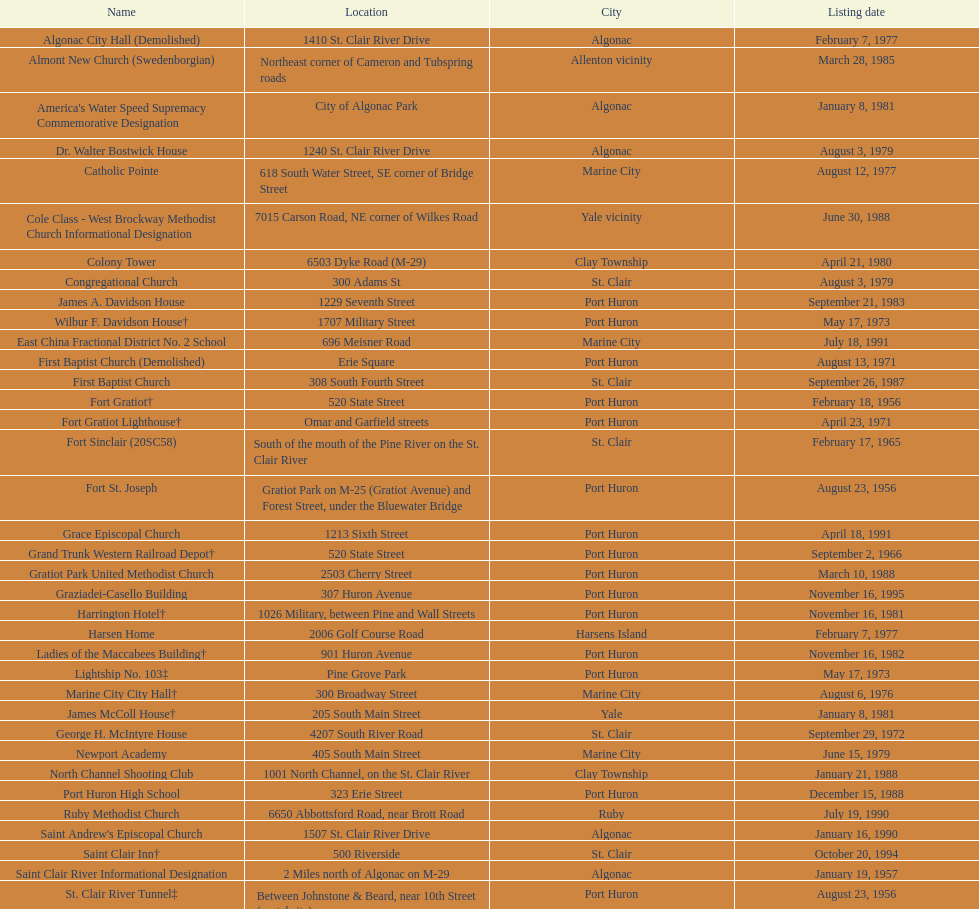How many names do not have images next to them? 41. 